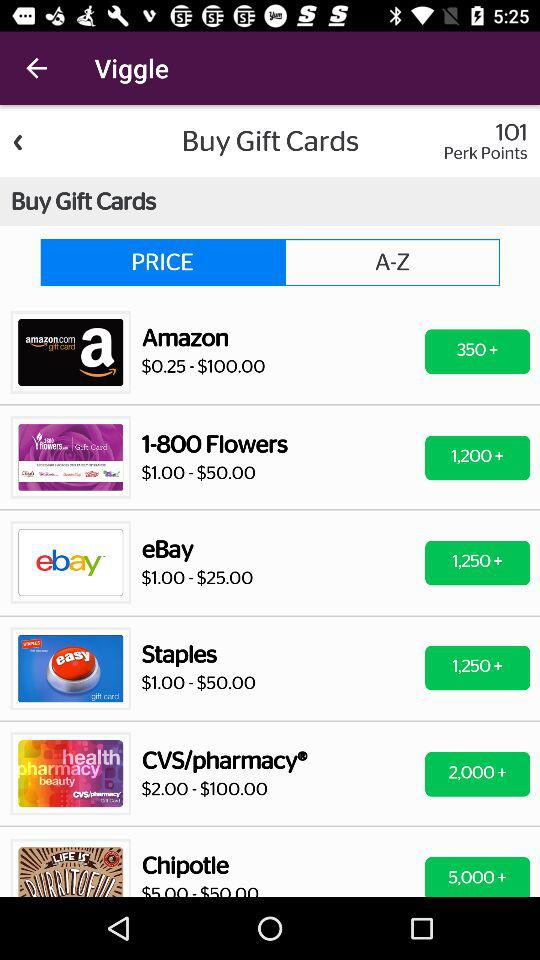How many Amazon gift cards are there? There are 350+ Amazon gift cards. 